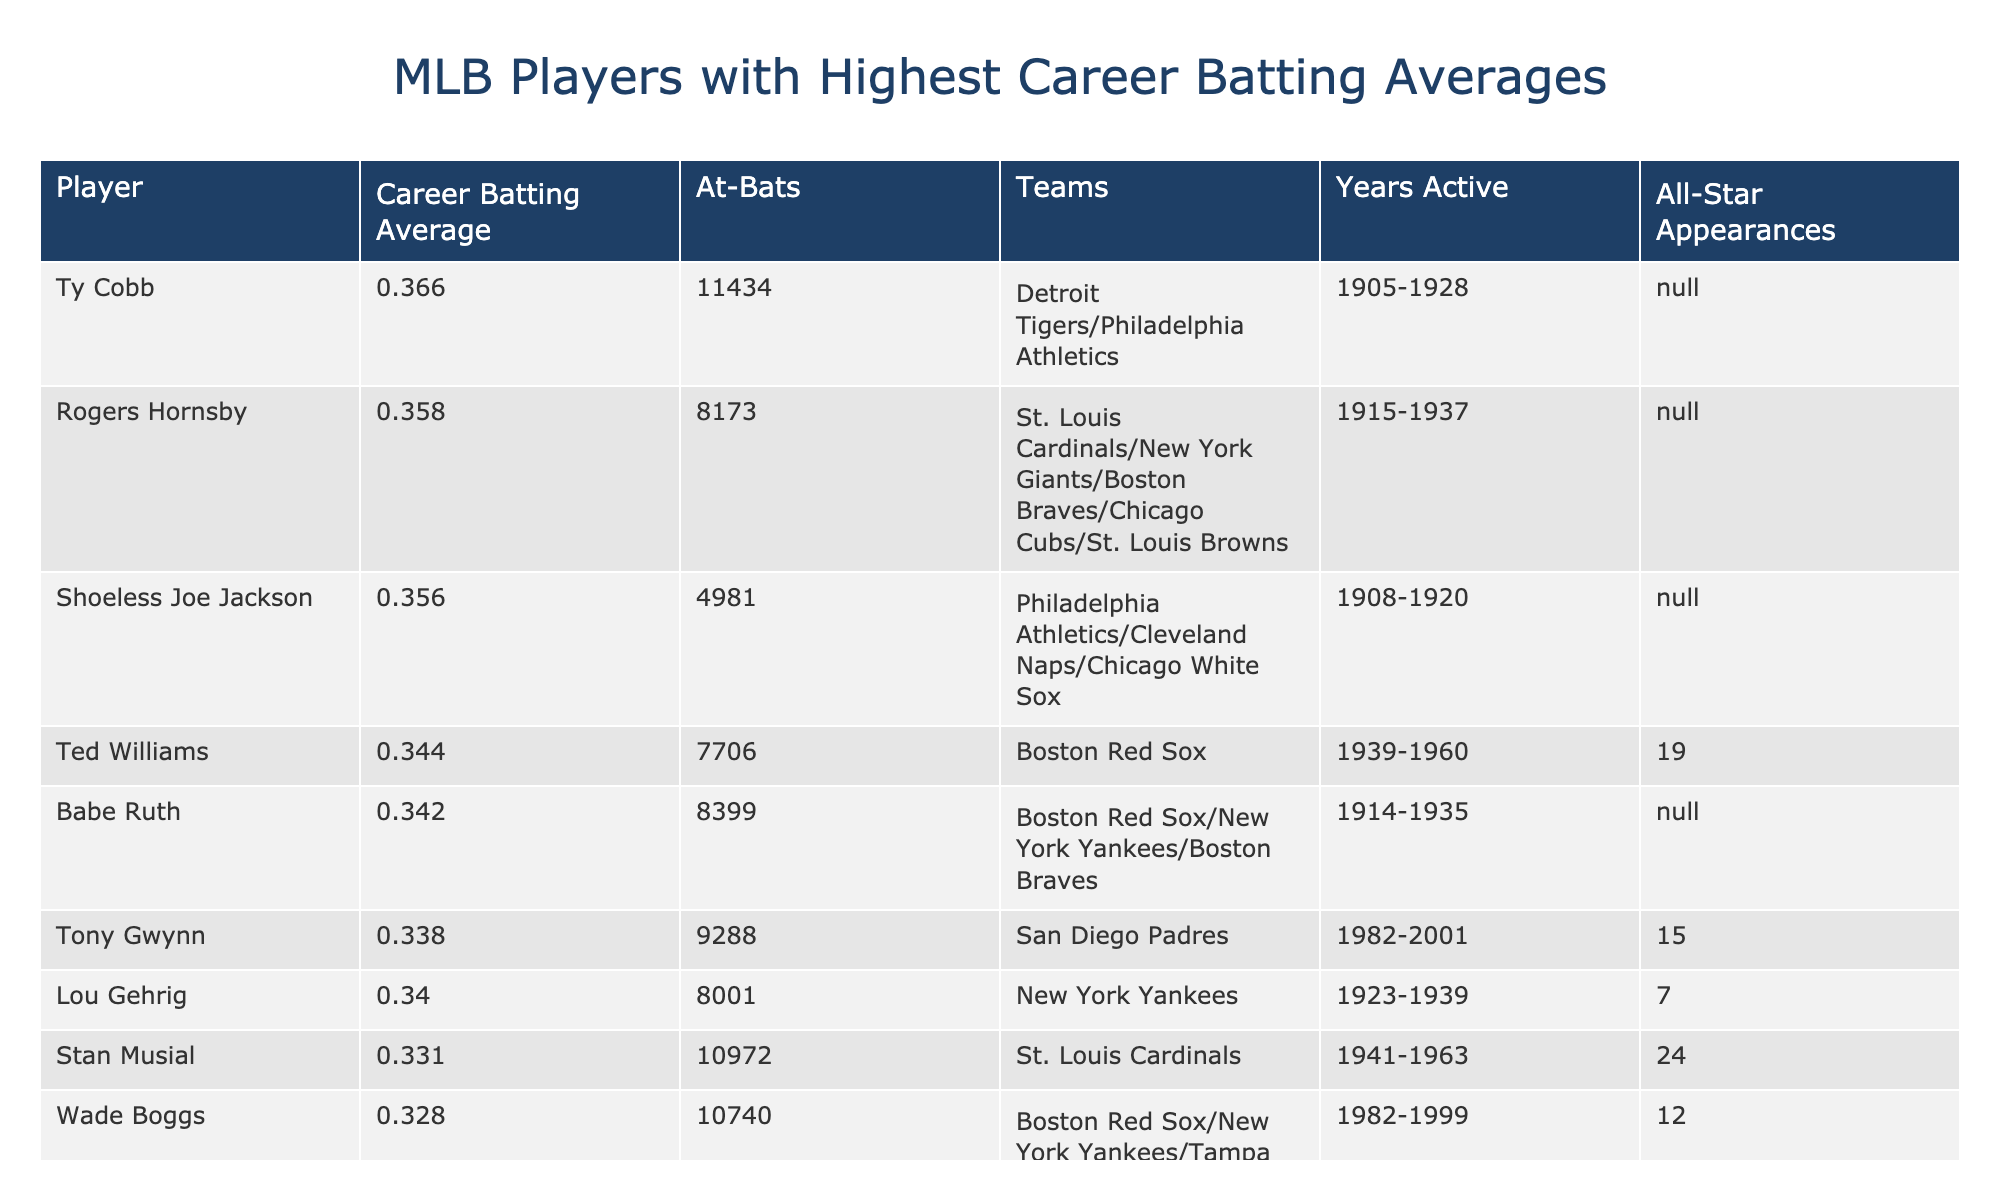What is the highest career batting average listed? The table shows that Ty Cobb has the highest career batting average at 0.366.
Answer: 0.366 Which player has the most at-bats with the highest batting average? Ty Cobb has the highest batting average of 0.366 along with 11,434 at-bats, which is the most in the table.
Answer: Ty Cobb Who had a career batting average of 0.344? The table lists Ted Williams with a career batting average of 0.344.
Answer: Ted Williams How many All-Star appearances does Tony Gwynn have? The table indicates that Tony Gwynn has 15 All-Star appearances.
Answer: 15 Which player had the fewest at-bats and what was their batting average? Shoeless Joe Jackson had the fewest at-bats, with 4,981, and a batting average of 0.356.
Answer: 0.356, 4981 What is the average career batting average of the players listed? To find the average, sum the batting averages (0.366 + 0.358 + 0.356 + 0.344 + 0.342 + 0.338 + 0.340 + 0.331 + 0.328 + 0.328 = 3.386) and divide by 10 (3.386/10 = 0.3386).
Answer: 0.3386 How many players have a batting average above 0.330? There are 5 players with a batting average above 0.330 (Ty Cobb, Rogers Hornsby, Ted Williams, Babe Ruth, and Lou Gehrig).
Answer: 5 Is there any player who was active before 1900 in this list? All players in the table started their careers in 1905 or later, so there are no players active before 1900.
Answer: No Which player has the most All-Star appearances among those listed? Ted Williams has the most All-Star appearances at 19, according to the table.
Answer: 19 What is the total number of at-bats for players with the highest batting averages above 0.330? The total at-bats for those players: (11,434 + 8,173 + 7,706 + 8,399 + 8,288 + 8,001) = 51,501.
Answer: 51501 Who was active the longest according to the years listed? Stan Musial was active the longest, from 1941 to 1963, totaling 22 years.
Answer: 22 years 